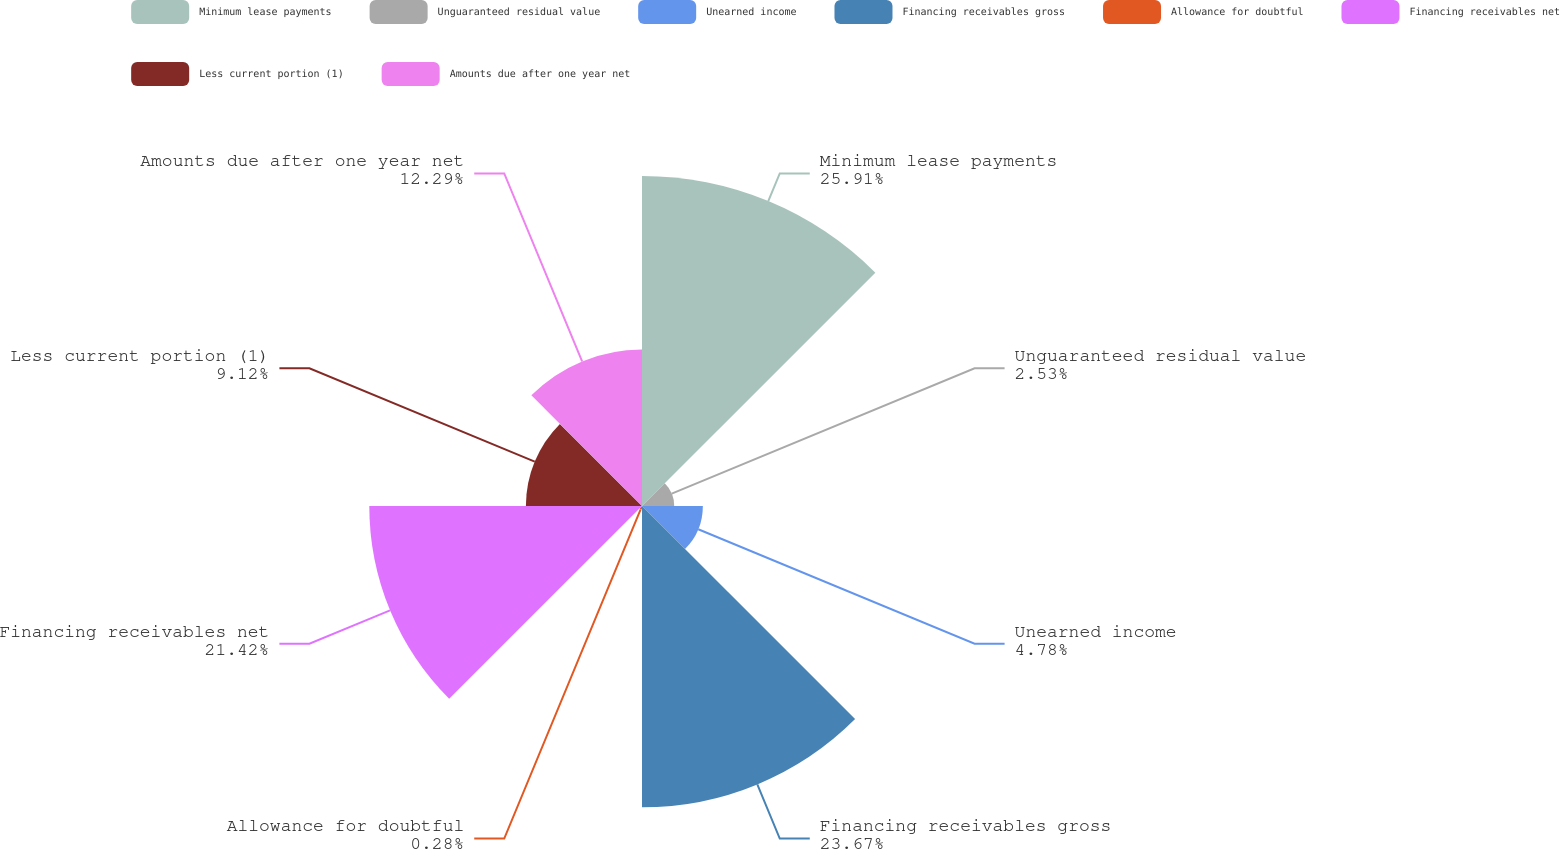Convert chart. <chart><loc_0><loc_0><loc_500><loc_500><pie_chart><fcel>Minimum lease payments<fcel>Unguaranteed residual value<fcel>Unearned income<fcel>Financing receivables gross<fcel>Allowance for doubtful<fcel>Financing receivables net<fcel>Less current portion (1)<fcel>Amounts due after one year net<nl><fcel>25.92%<fcel>2.53%<fcel>4.78%<fcel>23.67%<fcel>0.28%<fcel>21.42%<fcel>9.12%<fcel>12.29%<nl></chart> 